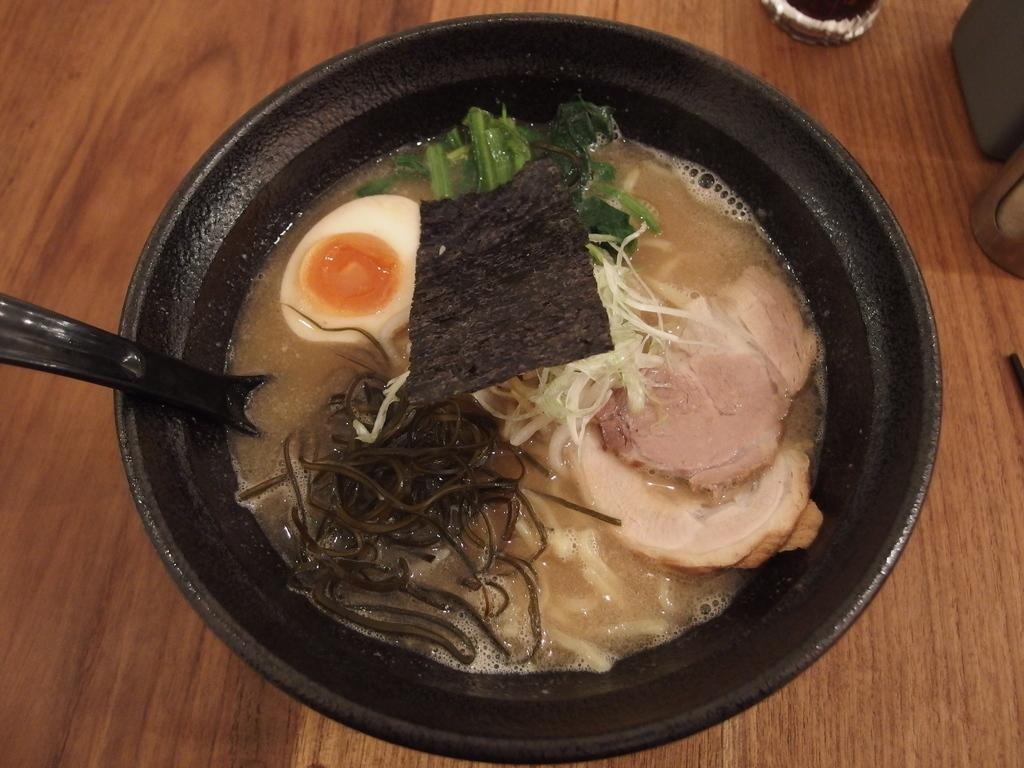What is the main object in the image? There is a bowl in the image. Where is the bowl located? The bowl is kept on a table. What is inside the bowl? There is food stuff in the bowl. What other piece of furniture is visible in the image? There is a table in the image. What type of things can be seen for sale at the market in the image? There is no market present in the image, so it is not possible to determine what items might be for sale. 